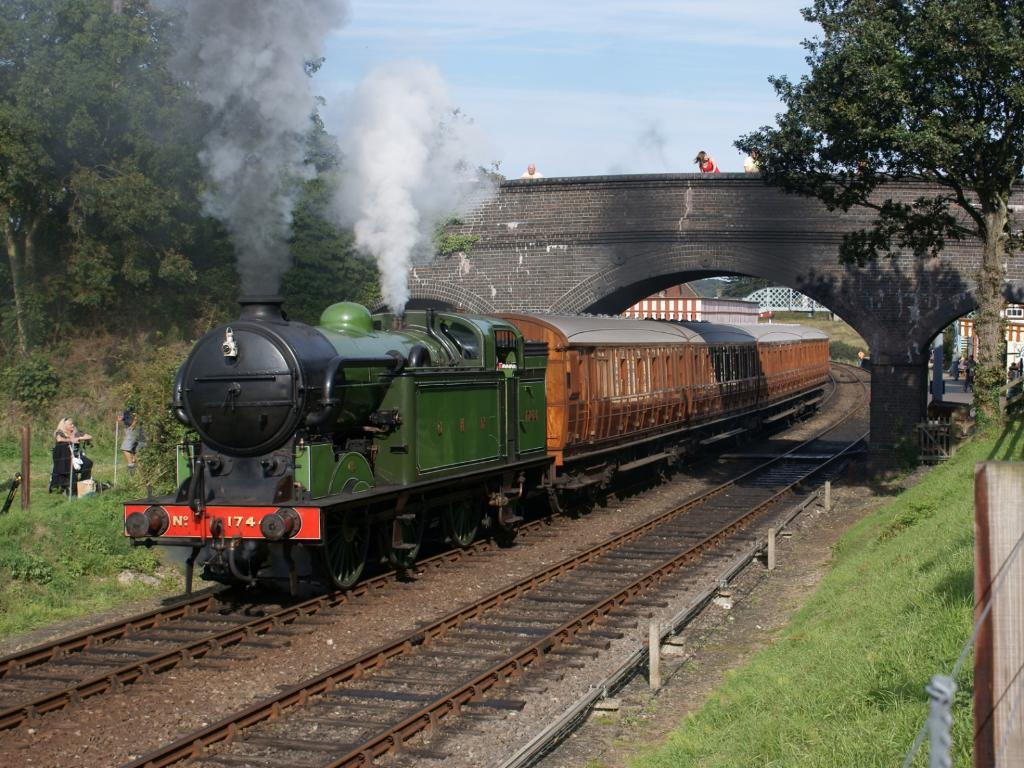What is the main subject of the image? The main subject of the image is a train. Where is the train located in the image? The train is on a railway track. What other structures can be seen in the image? There is a bridge and a truss in the image. What is the condition of the sky in the image? The sky is blue and white in color. What is visible coming out of the train in the image? Smoke is visible in the image. What type of barrier is present in the image? There is fencing in the image. How many rabbits can be seen hopping around the train in the image? There are no rabbits present in the image; it features a train on a railway track with a bridge, truss, fencing, and smoke. What invention is being used to power the train in the image? The image does not provide information about the type of engine or power source used to power the train. 